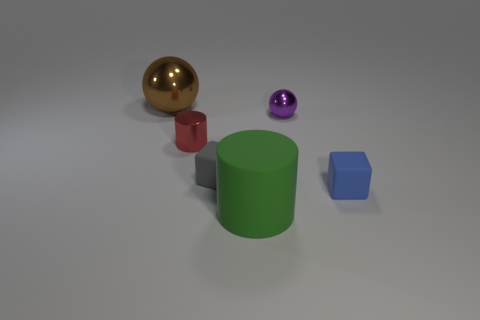The cylinder that is to the left of the cylinder in front of the small matte cube to the left of the small purple ball is made of what material?
Your answer should be very brief. Metal. Are there any blocks in front of the big rubber object?
Offer a very short reply. No. What is the shape of the brown shiny object that is the same size as the green matte thing?
Offer a very short reply. Sphere. Are the large ball and the gray thing made of the same material?
Your answer should be compact. No. How many shiny things are either red cylinders or green cylinders?
Provide a short and direct response. 1. There is a metallic ball behind the purple metal thing; is its color the same as the small sphere?
Offer a very short reply. No. What is the shape of the small object that is in front of the matte object to the left of the green thing?
Provide a succinct answer. Cube. What number of things are either tiny rubber cubes that are right of the purple thing or metal spheres to the right of the small red metallic thing?
Give a very brief answer. 2. There is a tiny object that is the same material as the purple sphere; what shape is it?
Keep it short and to the point. Cylinder. Are there any other things of the same color as the large matte object?
Provide a succinct answer. No. 